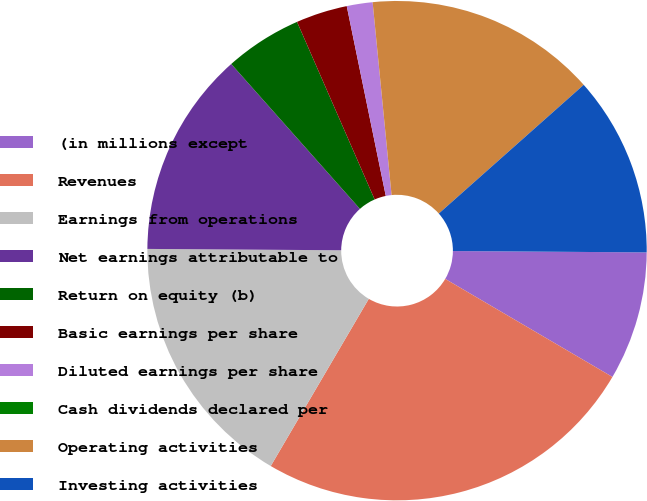Convert chart to OTSL. <chart><loc_0><loc_0><loc_500><loc_500><pie_chart><fcel>(in millions except<fcel>Revenues<fcel>Earnings from operations<fcel>Net earnings attributable to<fcel>Return on equity (b)<fcel>Basic earnings per share<fcel>Diluted earnings per share<fcel>Cash dividends declared per<fcel>Operating activities<fcel>Investing activities<nl><fcel>8.33%<fcel>25.0%<fcel>16.67%<fcel>13.33%<fcel>5.0%<fcel>3.33%<fcel>1.67%<fcel>0.0%<fcel>15.0%<fcel>11.67%<nl></chart> 